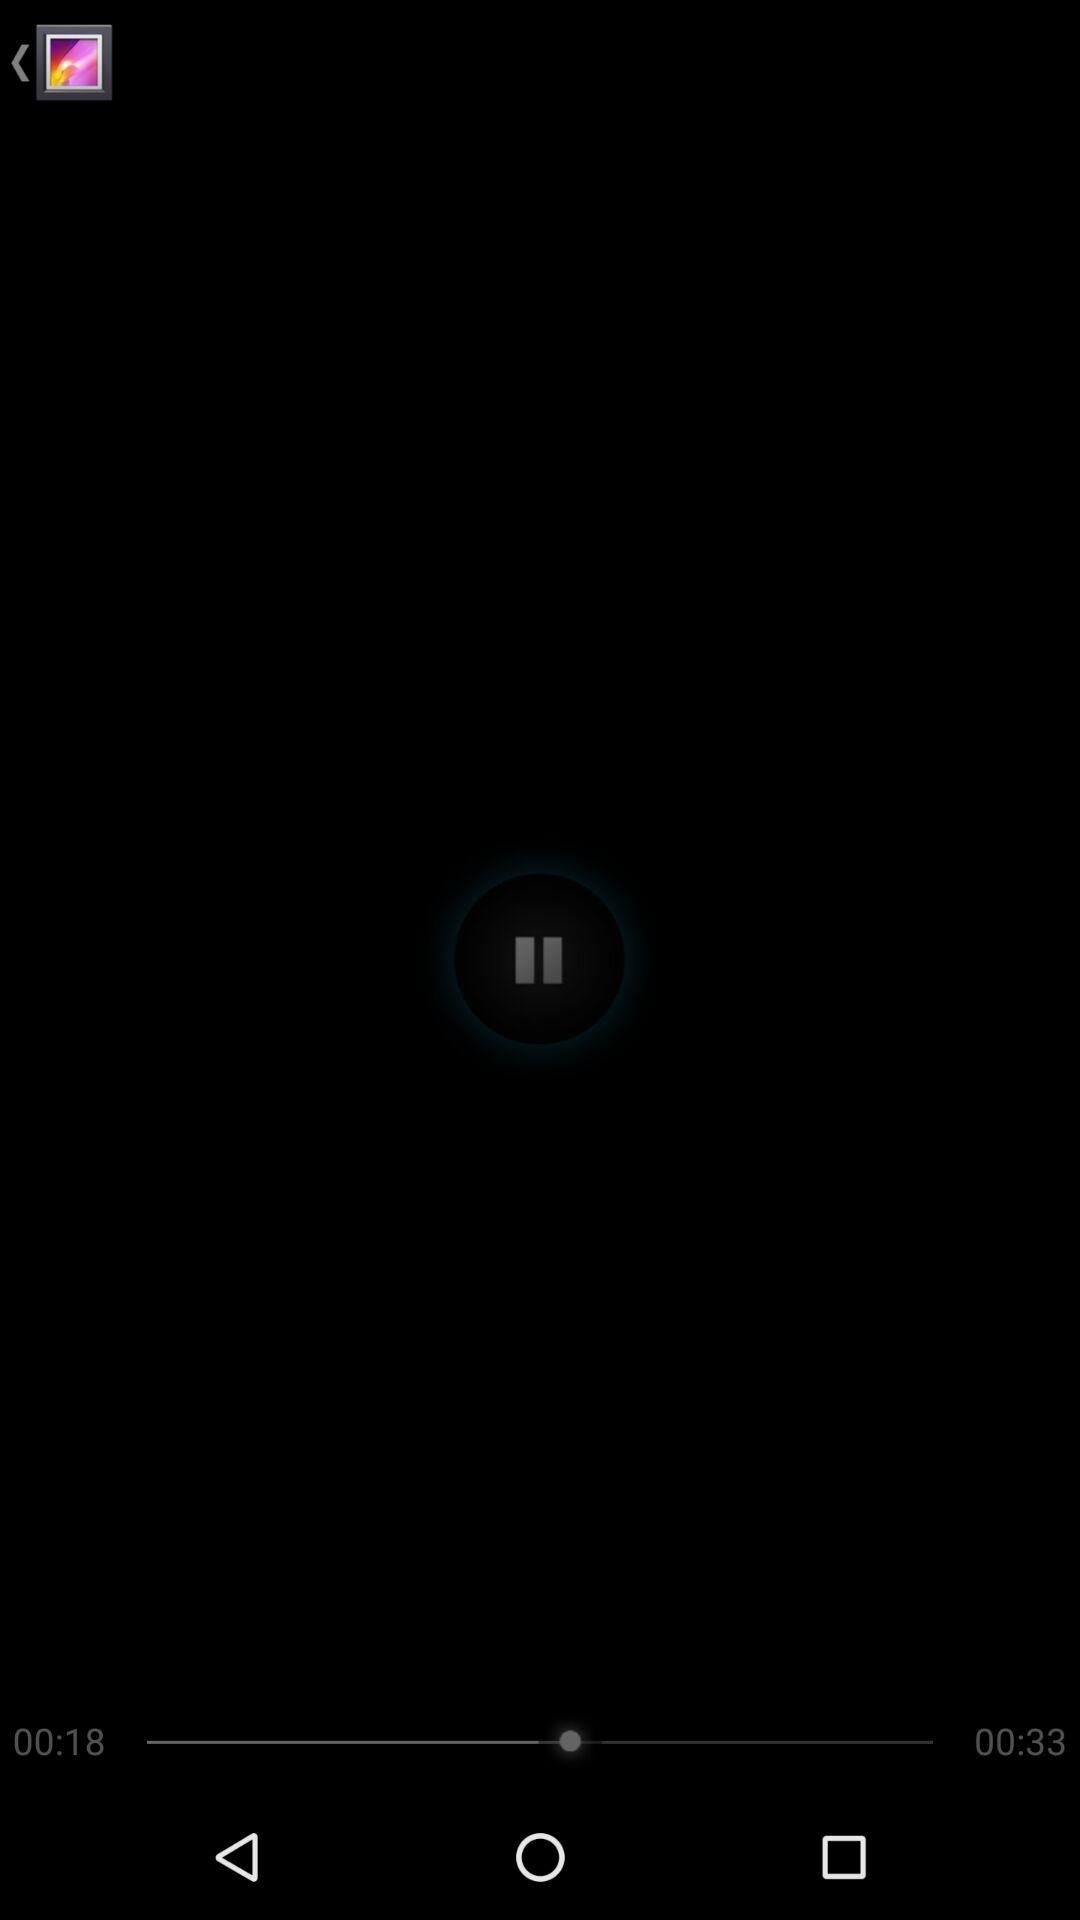How much of the video has been finished? The video's 00:18 second portion is over. 